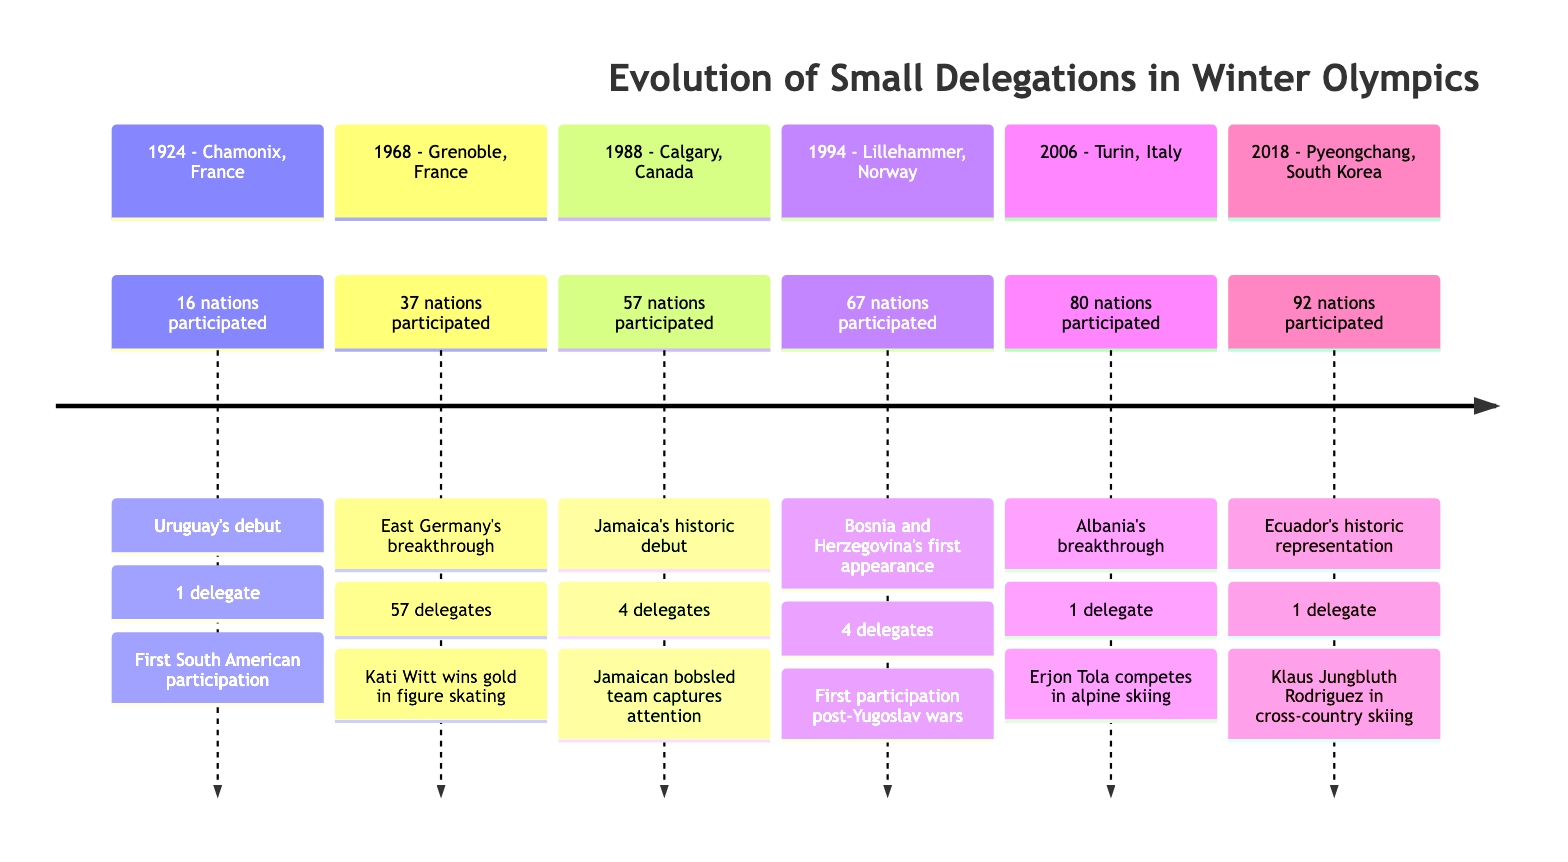What year did the inaugural Winter Olympics take place? The diagram indicates that the inaugural Winter Olympics occurred in 1924. This is found at the beginning of the timeline under the first event.
Answer: 1924 Which nation had the first participation in the Winter Olympics from South America? The timeline highlights Uruguay's participation in 1924, marking it as the first South American country to participate in the Winter Olympics.
Answer: Uruguay How many nations participated in the 1968 Winter Olympics? The diagram shows that 37 nations participated in the 1968 Winter Olympics held in Grenoble, France. This information is directly stated in the event detail.
Answer: 37 What notable achievement did East Germany accomplish in the 1968 Winter Olympics? The timeline specifies that East Germany, with 57 delegates, had Kati Witt win a gold medal in figure skating during the 1968 Winter Olympics. This is highlighted specifically in the details for that year.
Answer: Kati Witt wins gold Which country debuted at the Winter Olympics in 1988 with a bobsled team? The diagram details that Jamaica made its historic debut in 1988 at the Calgary Winter Olympics, which notably included a bobsled team.
Answer: Jamaica In what year did Ecuador compete in its first Winter Olympics? The timeline shows that Ecuador's Winter Olympic debut occurred in 2018 at Pyeongchang, South Korea, as noted in the last event of the timeline.
Answer: 2018 Which two years featured new Olympic debuts by smaller delegations in the timeline? The timeline includes Jamaica's debut in 1988 and Ecuador's debut in 2018, highlighting these as significant events for smaller delegations. This requires looking at the entries for both years.
Answer: 1988 and 2018 How many delegates did Albania have in the 2006 Winter Olympics? The event in 2006 specifies that Albania sent 1 delegate to the Winter Olympics in Turin, Italy, which is clearly stated in the details for that year.
Answer: 1 Did Bosnia and Herzegovina have more or fewer delegates than Jamaica in their respective debuts? The timeline indicates that Bosnia and Herzegovina had 4 delegates in 1994, while Jamaica had 4 in 1988. Therefore, the number of delegates is the same for both countries.
Answer: Same Which Winter Olympics featured the most participating nations? The timeline indicates that 92 nations participated in the 2018 Winter Olympics held in Pyeongchang, South Korea, which is the highest number presented in the timeline.
Answer: 92 